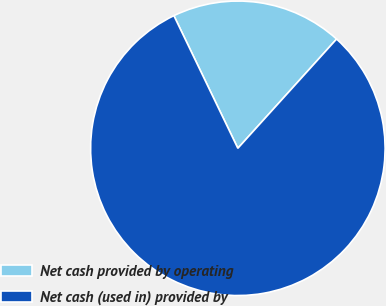Convert chart. <chart><loc_0><loc_0><loc_500><loc_500><pie_chart><fcel>Net cash provided by operating<fcel>Net cash (used in) provided by<nl><fcel>18.85%<fcel>81.15%<nl></chart> 